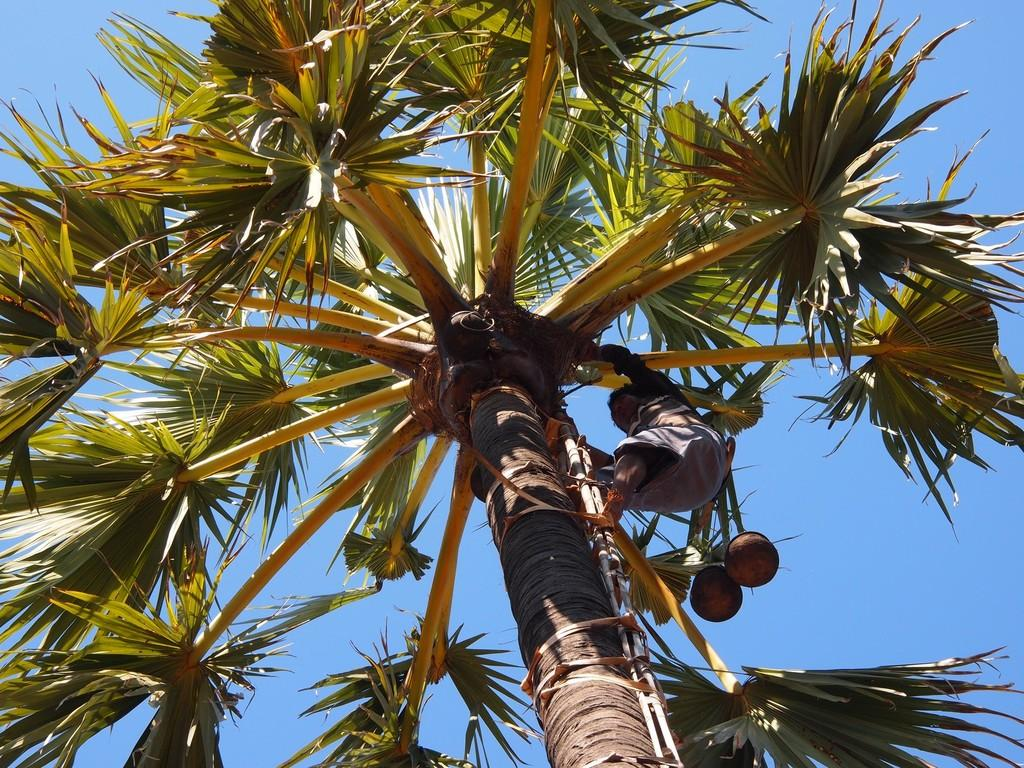What is the man doing in the image? The man is on a tree in the image. What objects can be seen besides the man? There are two pots in the image. How would you describe the weather in the image? The sky is cloudy in the image. How many tomatoes are hanging from the tree in the image? There are no tomatoes visible in the image; the man is the only subject on the tree. 